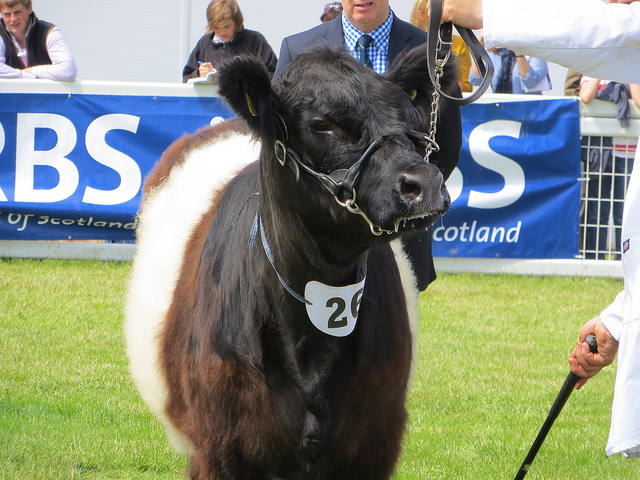Read all the text in this image. 2 S cotland BS Scotland OJ 